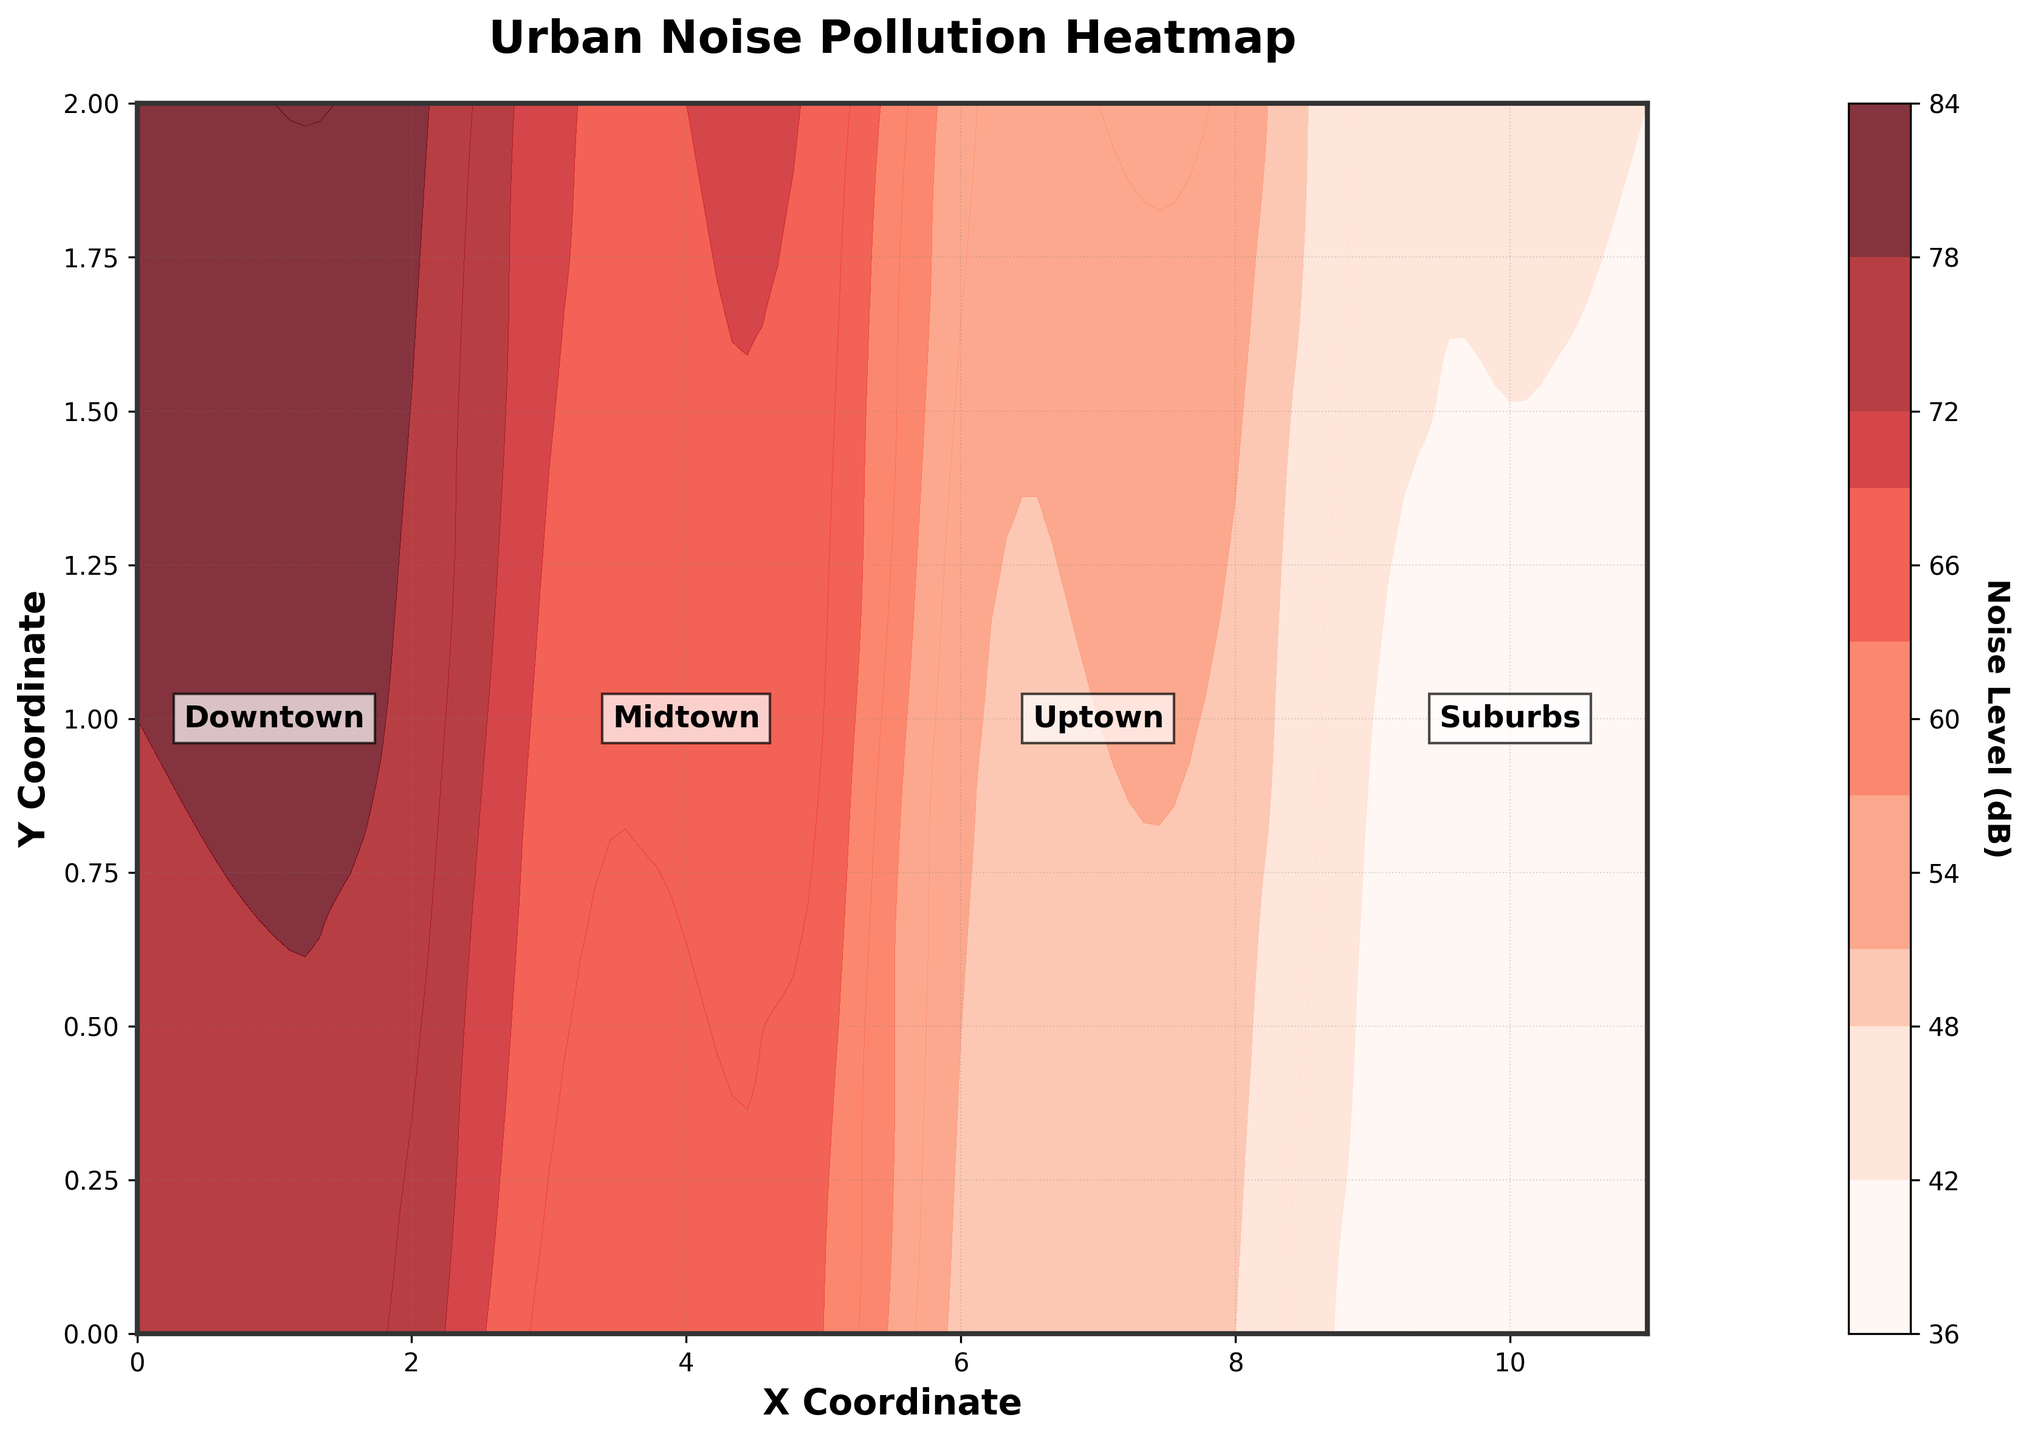What is the title of the plot? The title of the plot is located at the top of the figure. It reads "Urban Noise Pollution Heatmap," indicating the content of the plot.
Answer: Urban Noise Pollution Heatmap What do the X and Y labels represent? The labels along the X and Y axes are "X Coordinate" and "Y Coordinate," which help identify the position of different data points in the city.
Answer: X Coordinate and Y Coordinate How high are the noise levels in the Downtown area? The Downtown area is labeled at coordinates around (0,0) to (2,2). The contour shades in this region show noise levels ranging from 74 to 81 dB, suggesting fairly high noise pollution.
Answer: 74 to 81 dB Which area has the lowest noise pollution levels? Looking at the color gradient and neighborhood labels, the Suburbs area, located around coordinates (9,0) to (11,2), has the lightest shade indicating the lowest noise pollution levels, ranging from 38 to 44 dB.
Answer: Suburbs Compare the noise levels of Midtown and Uptown areas. The Midtown area (coordinates approximately from 3,0 to 5,2) shows noise levels ranging from 63 to 70 dB. Uptown (coordinates approximately from 6,0 to 8,2) has noise levels ranging from 48 to 55 dB. Thus, Midtown has higher noise levels.
Answer: Midtown What is the difference in noise pollution levels between the most polluted spot in Downtown and the least polluted spot in the Suburbs? The highest level in Downtown is 81 dB, and the lowest in Suburbs is 38 dB. The difference is calculated as 81 - 38 = 43 dB.
Answer: 43 dB What color represents the highest noise pollution on the plot? The color gradient goes from light to dark. The darkest shade on the plot, a deep red, represents the highest noise pollution levels.
Answer: Deep red Which neighborhood appears to be the quietest? By identifying the neighborhood with the lightest shaded color, the Suburbs have the lowest levels of noise pollution, making it the quietest neighborhood.
Answer: Suburbs Are there any significant variations in noise levels within any neighborhood? The Downtown area exhibits notable variations where noise levels range from 74 to 81 dB, indicating significant internal differences in noise pollution compared to other neighborhoods.
Answer: Downtown 